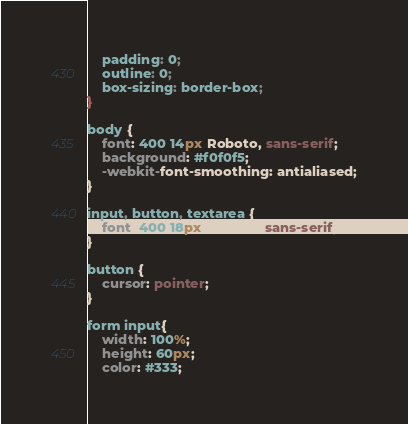Convert code to text. <code><loc_0><loc_0><loc_500><loc_500><_CSS_>    padding: 0;
    outline: 0;
    box-sizing: border-box;
}

body {
    font: 400 14px Roboto, sans-serif;
    background: #f0f0f5;
    -webkit-font-smoothing: antialiased;
}

input, button, textarea {
    font: 400 18px Roboto, sans-serif;
}

button {
    cursor: pointer;
}

form input{
    width: 100%;
    height: 60px;
    color: #333;</code> 